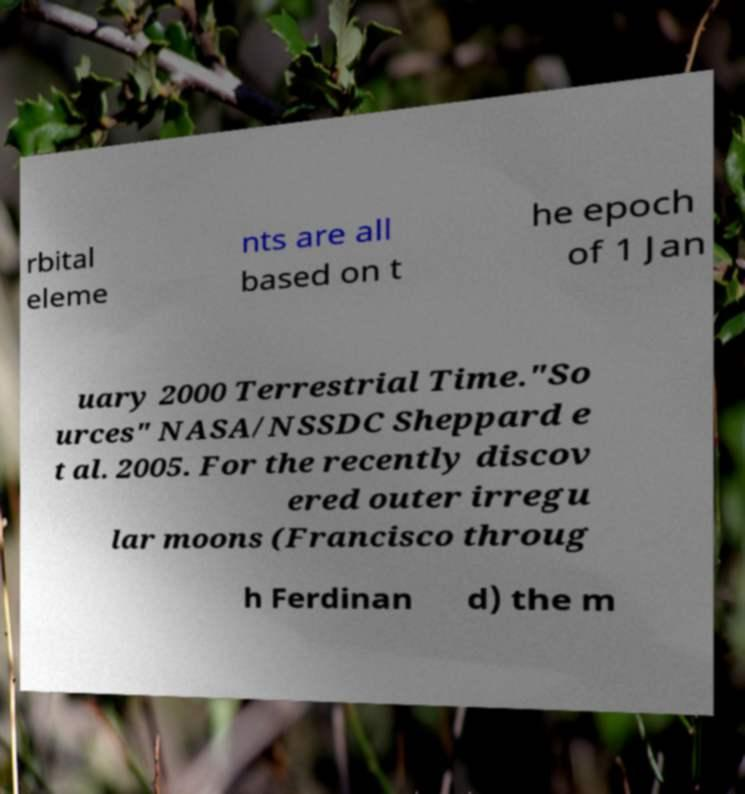There's text embedded in this image that I need extracted. Can you transcribe it verbatim? rbital eleme nts are all based on t he epoch of 1 Jan uary 2000 Terrestrial Time."So urces" NASA/NSSDC Sheppard e t al. 2005. For the recently discov ered outer irregu lar moons (Francisco throug h Ferdinan d) the m 